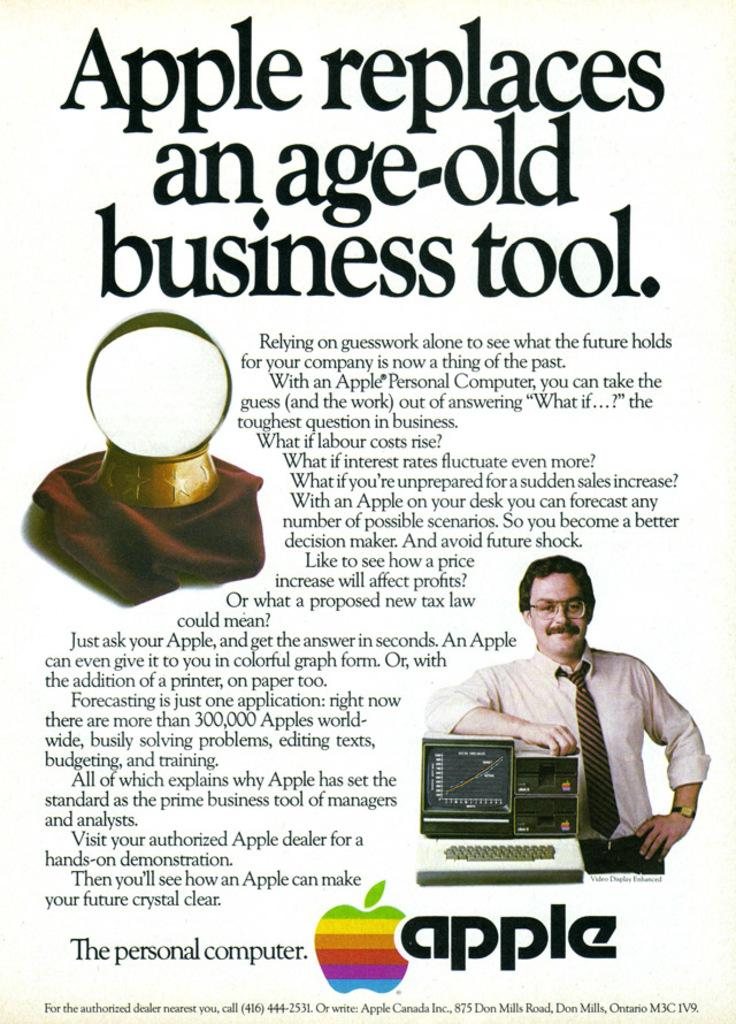Provide a one-sentence caption for the provided image. An old advertisement for an Apple personal computer. 